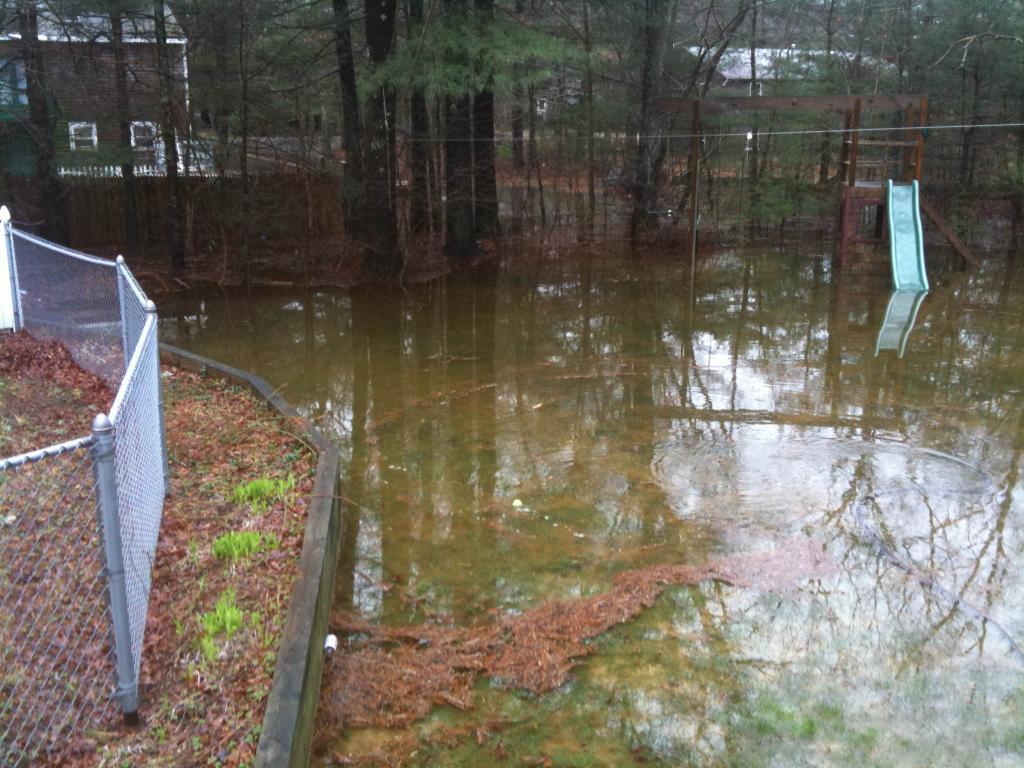Could you give a brief overview of what you see in this image? In this picture we can see water and a slide in water. We can see some fencing on the left side. There are few houses and trees in the background. 